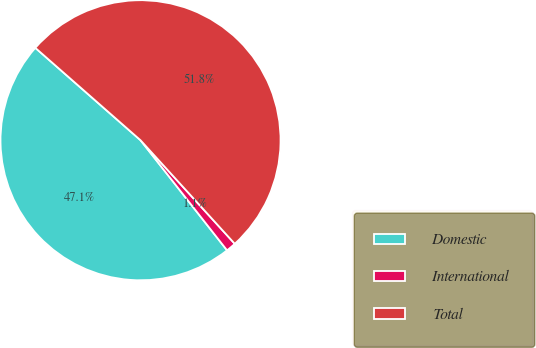Convert chart to OTSL. <chart><loc_0><loc_0><loc_500><loc_500><pie_chart><fcel>Domestic<fcel>International<fcel>Total<nl><fcel>47.07%<fcel>1.15%<fcel>51.78%<nl></chart> 